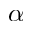Convert formula to latex. <formula><loc_0><loc_0><loc_500><loc_500>\alpha</formula> 